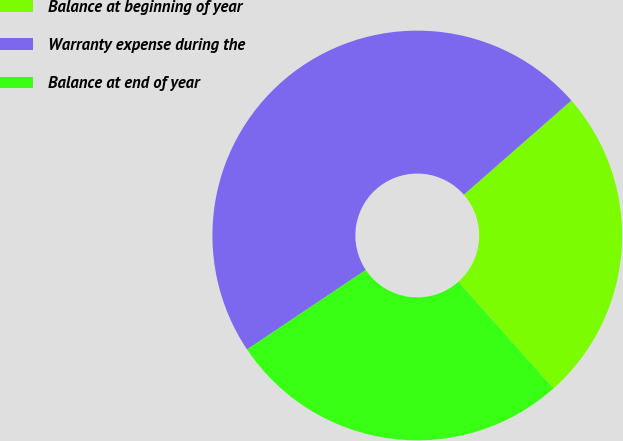<chart> <loc_0><loc_0><loc_500><loc_500><pie_chart><fcel>Balance at beginning of year<fcel>Warranty expense during the<fcel>Balance at end of year<nl><fcel>24.87%<fcel>47.94%<fcel>27.18%<nl></chart> 